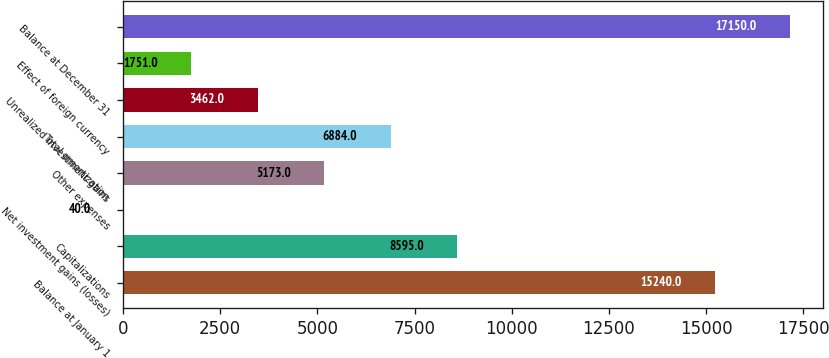<chart> <loc_0><loc_0><loc_500><loc_500><bar_chart><fcel>Balance at January 1<fcel>Capitalizations<fcel>Net investment gains (losses)<fcel>Other expenses<fcel>Total amortization<fcel>Unrealized investment gains<fcel>Effect of foreign currency<fcel>Balance at December 31<nl><fcel>15240<fcel>8595<fcel>40<fcel>5173<fcel>6884<fcel>3462<fcel>1751<fcel>17150<nl></chart> 